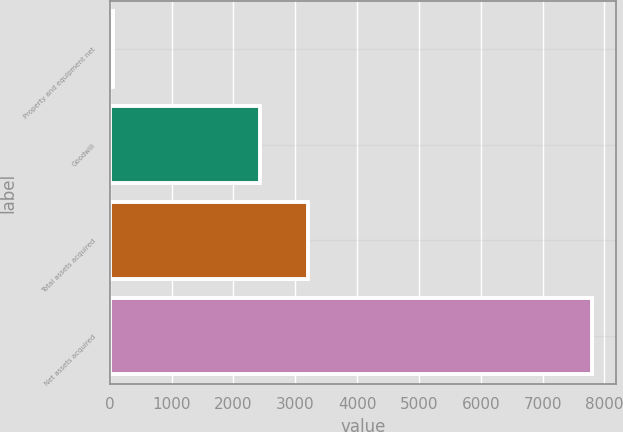<chart> <loc_0><loc_0><loc_500><loc_500><bar_chart><fcel>Property and equipment net<fcel>Goodwill<fcel>Total assets acquired<fcel>Net assets acquired<nl><fcel>57<fcel>2433<fcel>3207.3<fcel>7800<nl></chart> 